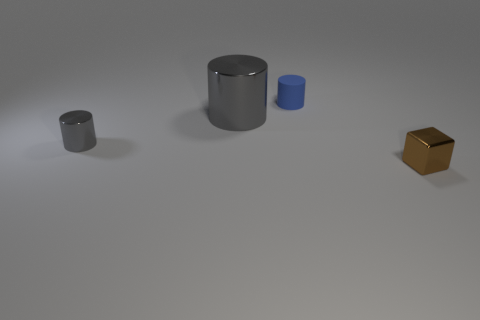Subtract 1 cylinders. How many cylinders are left? 2 Add 2 small gray shiny cylinders. How many objects exist? 6 Subtract all cylinders. How many objects are left? 1 Add 2 blue cylinders. How many blue cylinders exist? 3 Subtract 0 green balls. How many objects are left? 4 Subtract all small blue objects. Subtract all small brown metal things. How many objects are left? 2 Add 4 brown cubes. How many brown cubes are left? 5 